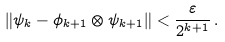Convert formula to latex. <formula><loc_0><loc_0><loc_500><loc_500>\| \psi _ { k } - \phi _ { k + 1 } \otimes \psi _ { k + 1 } \| < \frac { \varepsilon } { 2 ^ { k + 1 } } \, .</formula> 